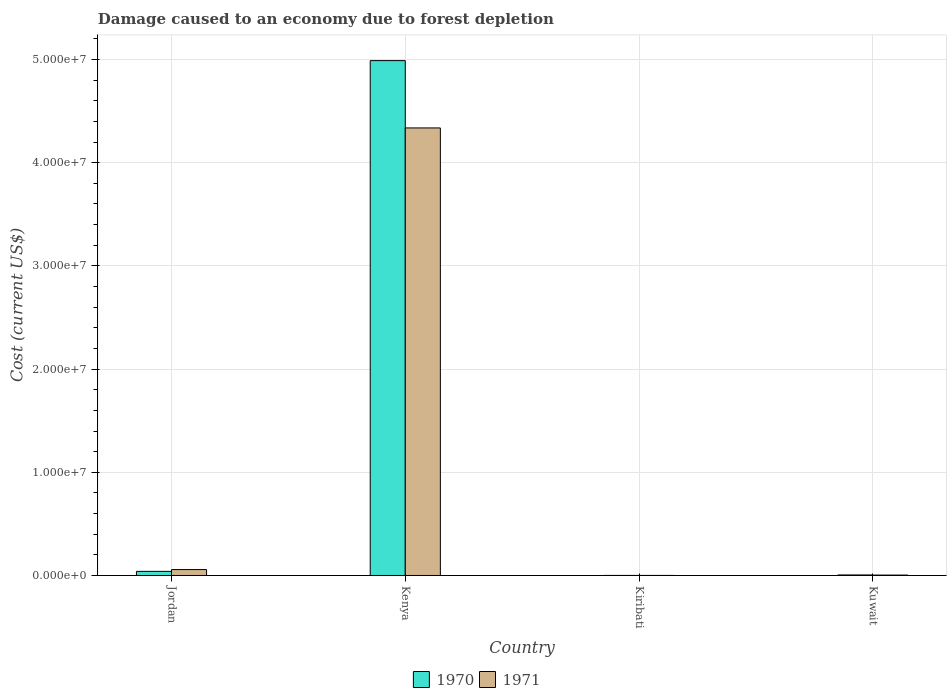How many different coloured bars are there?
Your answer should be very brief. 2. How many groups of bars are there?
Provide a succinct answer. 4. Are the number of bars on each tick of the X-axis equal?
Ensure brevity in your answer.  Yes. How many bars are there on the 2nd tick from the left?
Offer a terse response. 2. How many bars are there on the 4th tick from the right?
Make the answer very short. 2. What is the label of the 3rd group of bars from the left?
Provide a succinct answer. Kiribati. In how many cases, is the number of bars for a given country not equal to the number of legend labels?
Provide a succinct answer. 0. What is the cost of damage caused due to forest depletion in 1970 in Kuwait?
Your answer should be compact. 4.89e+04. Across all countries, what is the maximum cost of damage caused due to forest depletion in 1970?
Offer a terse response. 4.99e+07. Across all countries, what is the minimum cost of damage caused due to forest depletion in 1971?
Your answer should be very brief. 2640.68. In which country was the cost of damage caused due to forest depletion in 1970 maximum?
Your answer should be compact. Kenya. In which country was the cost of damage caused due to forest depletion in 1970 minimum?
Offer a very short reply. Kiribati. What is the total cost of damage caused due to forest depletion in 1970 in the graph?
Keep it short and to the point. 5.03e+07. What is the difference between the cost of damage caused due to forest depletion in 1970 in Kenya and that in Kuwait?
Ensure brevity in your answer.  4.98e+07. What is the difference between the cost of damage caused due to forest depletion in 1970 in Kuwait and the cost of damage caused due to forest depletion in 1971 in Kenya?
Your answer should be compact. -4.33e+07. What is the average cost of damage caused due to forest depletion in 1970 per country?
Your response must be concise. 1.26e+07. What is the difference between the cost of damage caused due to forest depletion of/in 1971 and cost of damage caused due to forest depletion of/in 1970 in Kenya?
Give a very brief answer. -6.52e+06. In how many countries, is the cost of damage caused due to forest depletion in 1970 greater than 6000000 US$?
Provide a succinct answer. 1. What is the ratio of the cost of damage caused due to forest depletion in 1970 in Jordan to that in Kiribati?
Give a very brief answer. 137.74. What is the difference between the highest and the second highest cost of damage caused due to forest depletion in 1971?
Keep it short and to the point. 4.28e+07. What is the difference between the highest and the lowest cost of damage caused due to forest depletion in 1970?
Your response must be concise. 4.99e+07. In how many countries, is the cost of damage caused due to forest depletion in 1970 greater than the average cost of damage caused due to forest depletion in 1970 taken over all countries?
Offer a terse response. 1. How many bars are there?
Your answer should be very brief. 8. How many countries are there in the graph?
Your answer should be very brief. 4. What is the difference between two consecutive major ticks on the Y-axis?
Your answer should be very brief. 1.00e+07. Are the values on the major ticks of Y-axis written in scientific E-notation?
Offer a terse response. Yes. Does the graph contain grids?
Your answer should be compact. Yes. Where does the legend appear in the graph?
Provide a short and direct response. Bottom center. How are the legend labels stacked?
Your response must be concise. Horizontal. What is the title of the graph?
Keep it short and to the point. Damage caused to an economy due to forest depletion. What is the label or title of the Y-axis?
Make the answer very short. Cost (current US$). What is the Cost (current US$) of 1970 in Jordan?
Make the answer very short. 3.97e+05. What is the Cost (current US$) in 1971 in Jordan?
Provide a succinct answer. 5.72e+05. What is the Cost (current US$) of 1970 in Kenya?
Offer a very short reply. 4.99e+07. What is the Cost (current US$) in 1971 in Kenya?
Ensure brevity in your answer.  4.34e+07. What is the Cost (current US$) of 1970 in Kiribati?
Offer a very short reply. 2885.29. What is the Cost (current US$) in 1971 in Kiribati?
Provide a short and direct response. 2640.68. What is the Cost (current US$) in 1970 in Kuwait?
Give a very brief answer. 4.89e+04. What is the Cost (current US$) of 1971 in Kuwait?
Your answer should be compact. 3.78e+04. Across all countries, what is the maximum Cost (current US$) in 1970?
Your response must be concise. 4.99e+07. Across all countries, what is the maximum Cost (current US$) of 1971?
Provide a succinct answer. 4.34e+07. Across all countries, what is the minimum Cost (current US$) in 1970?
Your response must be concise. 2885.29. Across all countries, what is the minimum Cost (current US$) in 1971?
Offer a very short reply. 2640.68. What is the total Cost (current US$) of 1970 in the graph?
Offer a very short reply. 5.03e+07. What is the total Cost (current US$) of 1971 in the graph?
Give a very brief answer. 4.40e+07. What is the difference between the Cost (current US$) of 1970 in Jordan and that in Kenya?
Offer a very short reply. -4.95e+07. What is the difference between the Cost (current US$) in 1971 in Jordan and that in Kenya?
Ensure brevity in your answer.  -4.28e+07. What is the difference between the Cost (current US$) of 1970 in Jordan and that in Kiribati?
Your answer should be compact. 3.95e+05. What is the difference between the Cost (current US$) in 1971 in Jordan and that in Kiribati?
Make the answer very short. 5.69e+05. What is the difference between the Cost (current US$) of 1970 in Jordan and that in Kuwait?
Provide a short and direct response. 3.49e+05. What is the difference between the Cost (current US$) in 1971 in Jordan and that in Kuwait?
Your response must be concise. 5.34e+05. What is the difference between the Cost (current US$) of 1970 in Kenya and that in Kiribati?
Keep it short and to the point. 4.99e+07. What is the difference between the Cost (current US$) in 1971 in Kenya and that in Kiribati?
Provide a short and direct response. 4.34e+07. What is the difference between the Cost (current US$) of 1970 in Kenya and that in Kuwait?
Provide a succinct answer. 4.98e+07. What is the difference between the Cost (current US$) of 1971 in Kenya and that in Kuwait?
Make the answer very short. 4.33e+07. What is the difference between the Cost (current US$) in 1970 in Kiribati and that in Kuwait?
Your answer should be very brief. -4.60e+04. What is the difference between the Cost (current US$) in 1971 in Kiribati and that in Kuwait?
Offer a very short reply. -3.51e+04. What is the difference between the Cost (current US$) of 1970 in Jordan and the Cost (current US$) of 1971 in Kenya?
Provide a succinct answer. -4.30e+07. What is the difference between the Cost (current US$) in 1970 in Jordan and the Cost (current US$) in 1971 in Kiribati?
Your response must be concise. 3.95e+05. What is the difference between the Cost (current US$) in 1970 in Jordan and the Cost (current US$) in 1971 in Kuwait?
Give a very brief answer. 3.60e+05. What is the difference between the Cost (current US$) in 1970 in Kenya and the Cost (current US$) in 1971 in Kiribati?
Your response must be concise. 4.99e+07. What is the difference between the Cost (current US$) in 1970 in Kenya and the Cost (current US$) in 1971 in Kuwait?
Keep it short and to the point. 4.99e+07. What is the difference between the Cost (current US$) in 1970 in Kiribati and the Cost (current US$) in 1971 in Kuwait?
Offer a terse response. -3.49e+04. What is the average Cost (current US$) in 1970 per country?
Offer a very short reply. 1.26e+07. What is the average Cost (current US$) in 1971 per country?
Give a very brief answer. 1.10e+07. What is the difference between the Cost (current US$) of 1970 and Cost (current US$) of 1971 in Jordan?
Your answer should be very brief. -1.74e+05. What is the difference between the Cost (current US$) of 1970 and Cost (current US$) of 1971 in Kenya?
Provide a short and direct response. 6.52e+06. What is the difference between the Cost (current US$) of 1970 and Cost (current US$) of 1971 in Kiribati?
Ensure brevity in your answer.  244.61. What is the difference between the Cost (current US$) in 1970 and Cost (current US$) in 1971 in Kuwait?
Ensure brevity in your answer.  1.11e+04. What is the ratio of the Cost (current US$) of 1970 in Jordan to that in Kenya?
Offer a terse response. 0.01. What is the ratio of the Cost (current US$) of 1971 in Jordan to that in Kenya?
Make the answer very short. 0.01. What is the ratio of the Cost (current US$) in 1970 in Jordan to that in Kiribati?
Keep it short and to the point. 137.74. What is the ratio of the Cost (current US$) of 1971 in Jordan to that in Kiribati?
Your answer should be compact. 216.43. What is the ratio of the Cost (current US$) in 1970 in Jordan to that in Kuwait?
Your answer should be very brief. 8.13. What is the ratio of the Cost (current US$) in 1971 in Jordan to that in Kuwait?
Your answer should be very brief. 15.14. What is the ratio of the Cost (current US$) of 1970 in Kenya to that in Kiribati?
Provide a short and direct response. 1.73e+04. What is the ratio of the Cost (current US$) of 1971 in Kenya to that in Kiribati?
Your answer should be very brief. 1.64e+04. What is the ratio of the Cost (current US$) in 1970 in Kenya to that in Kuwait?
Ensure brevity in your answer.  1020.4. What is the ratio of the Cost (current US$) of 1971 in Kenya to that in Kuwait?
Give a very brief answer. 1148.83. What is the ratio of the Cost (current US$) in 1970 in Kiribati to that in Kuwait?
Your response must be concise. 0.06. What is the ratio of the Cost (current US$) in 1971 in Kiribati to that in Kuwait?
Provide a short and direct response. 0.07. What is the difference between the highest and the second highest Cost (current US$) of 1970?
Make the answer very short. 4.95e+07. What is the difference between the highest and the second highest Cost (current US$) of 1971?
Make the answer very short. 4.28e+07. What is the difference between the highest and the lowest Cost (current US$) of 1970?
Offer a very short reply. 4.99e+07. What is the difference between the highest and the lowest Cost (current US$) of 1971?
Provide a short and direct response. 4.34e+07. 